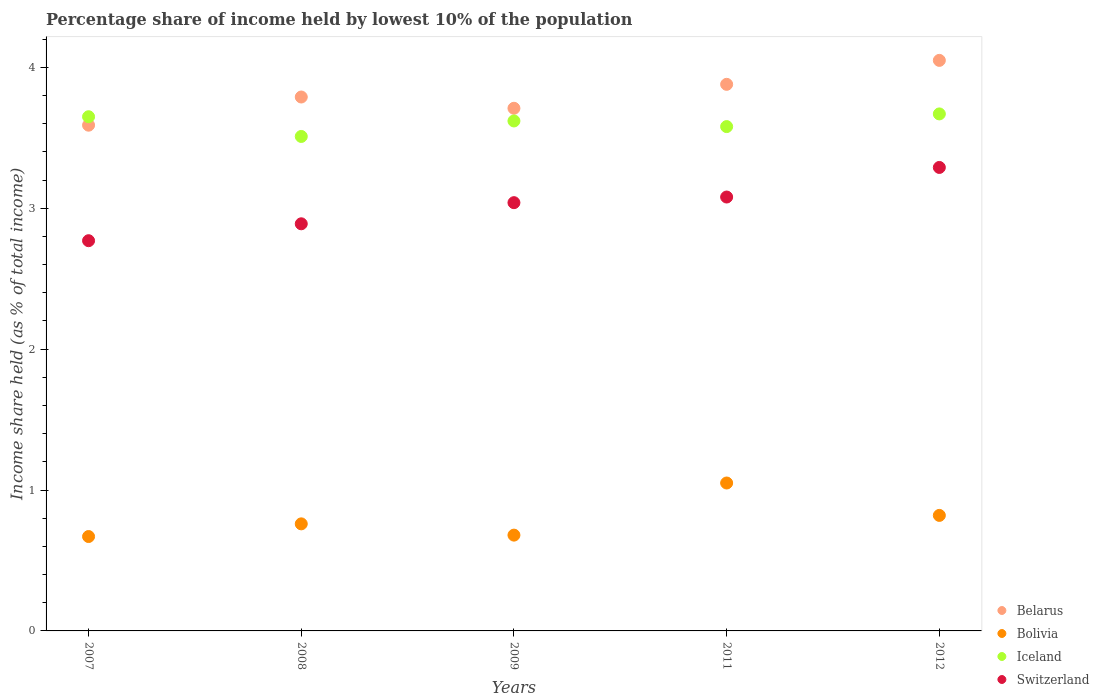Is the number of dotlines equal to the number of legend labels?
Keep it short and to the point. Yes. What is the percentage share of income held by lowest 10% of the population in Switzerland in 2011?
Your response must be concise. 3.08. Across all years, what is the minimum percentage share of income held by lowest 10% of the population in Switzerland?
Provide a short and direct response. 2.77. In which year was the percentage share of income held by lowest 10% of the population in Iceland maximum?
Give a very brief answer. 2012. In which year was the percentage share of income held by lowest 10% of the population in Belarus minimum?
Provide a short and direct response. 2007. What is the total percentage share of income held by lowest 10% of the population in Iceland in the graph?
Offer a terse response. 18.03. What is the difference between the percentage share of income held by lowest 10% of the population in Belarus in 2007 and that in 2008?
Your answer should be very brief. -0.2. What is the difference between the percentage share of income held by lowest 10% of the population in Switzerland in 2011 and the percentage share of income held by lowest 10% of the population in Bolivia in 2007?
Offer a terse response. 2.41. What is the average percentage share of income held by lowest 10% of the population in Iceland per year?
Offer a terse response. 3.61. What is the ratio of the percentage share of income held by lowest 10% of the population in Iceland in 2008 to that in 2011?
Your response must be concise. 0.98. Is the difference between the percentage share of income held by lowest 10% of the population in Iceland in 2007 and 2009 greater than the difference between the percentage share of income held by lowest 10% of the population in Switzerland in 2007 and 2009?
Your response must be concise. Yes. What is the difference between the highest and the second highest percentage share of income held by lowest 10% of the population in Bolivia?
Make the answer very short. 0.23. What is the difference between the highest and the lowest percentage share of income held by lowest 10% of the population in Iceland?
Provide a succinct answer. 0.16. Is the sum of the percentage share of income held by lowest 10% of the population in Switzerland in 2008 and 2011 greater than the maximum percentage share of income held by lowest 10% of the population in Belarus across all years?
Make the answer very short. Yes. Does the percentage share of income held by lowest 10% of the population in Belarus monotonically increase over the years?
Your answer should be very brief. No. Is the percentage share of income held by lowest 10% of the population in Switzerland strictly greater than the percentage share of income held by lowest 10% of the population in Bolivia over the years?
Your answer should be very brief. Yes. How many dotlines are there?
Provide a short and direct response. 4. How many years are there in the graph?
Make the answer very short. 5. Does the graph contain grids?
Your answer should be very brief. No. How many legend labels are there?
Make the answer very short. 4. What is the title of the graph?
Ensure brevity in your answer.  Percentage share of income held by lowest 10% of the population. What is the label or title of the X-axis?
Your answer should be very brief. Years. What is the label or title of the Y-axis?
Keep it short and to the point. Income share held (as % of total income). What is the Income share held (as % of total income) of Belarus in 2007?
Your answer should be very brief. 3.59. What is the Income share held (as % of total income) of Bolivia in 2007?
Offer a terse response. 0.67. What is the Income share held (as % of total income) in Iceland in 2007?
Keep it short and to the point. 3.65. What is the Income share held (as % of total income) in Switzerland in 2007?
Give a very brief answer. 2.77. What is the Income share held (as % of total income) in Belarus in 2008?
Provide a succinct answer. 3.79. What is the Income share held (as % of total income) of Bolivia in 2008?
Offer a terse response. 0.76. What is the Income share held (as % of total income) in Iceland in 2008?
Keep it short and to the point. 3.51. What is the Income share held (as % of total income) of Switzerland in 2008?
Ensure brevity in your answer.  2.89. What is the Income share held (as % of total income) in Belarus in 2009?
Ensure brevity in your answer.  3.71. What is the Income share held (as % of total income) in Bolivia in 2009?
Your response must be concise. 0.68. What is the Income share held (as % of total income) in Iceland in 2009?
Your answer should be compact. 3.62. What is the Income share held (as % of total income) in Switzerland in 2009?
Make the answer very short. 3.04. What is the Income share held (as % of total income) in Belarus in 2011?
Your answer should be compact. 3.88. What is the Income share held (as % of total income) in Iceland in 2011?
Offer a very short reply. 3.58. What is the Income share held (as % of total income) of Switzerland in 2011?
Provide a succinct answer. 3.08. What is the Income share held (as % of total income) of Belarus in 2012?
Provide a short and direct response. 4.05. What is the Income share held (as % of total income) of Bolivia in 2012?
Your response must be concise. 0.82. What is the Income share held (as % of total income) of Iceland in 2012?
Ensure brevity in your answer.  3.67. What is the Income share held (as % of total income) of Switzerland in 2012?
Your answer should be compact. 3.29. Across all years, what is the maximum Income share held (as % of total income) of Belarus?
Provide a short and direct response. 4.05. Across all years, what is the maximum Income share held (as % of total income) in Bolivia?
Your response must be concise. 1.05. Across all years, what is the maximum Income share held (as % of total income) in Iceland?
Make the answer very short. 3.67. Across all years, what is the maximum Income share held (as % of total income) in Switzerland?
Make the answer very short. 3.29. Across all years, what is the minimum Income share held (as % of total income) in Belarus?
Make the answer very short. 3.59. Across all years, what is the minimum Income share held (as % of total income) of Bolivia?
Your answer should be compact. 0.67. Across all years, what is the minimum Income share held (as % of total income) in Iceland?
Your response must be concise. 3.51. Across all years, what is the minimum Income share held (as % of total income) of Switzerland?
Your answer should be very brief. 2.77. What is the total Income share held (as % of total income) in Belarus in the graph?
Provide a succinct answer. 19.02. What is the total Income share held (as % of total income) in Bolivia in the graph?
Provide a succinct answer. 3.98. What is the total Income share held (as % of total income) in Iceland in the graph?
Offer a very short reply. 18.03. What is the total Income share held (as % of total income) of Switzerland in the graph?
Offer a terse response. 15.07. What is the difference between the Income share held (as % of total income) in Belarus in 2007 and that in 2008?
Your answer should be compact. -0.2. What is the difference between the Income share held (as % of total income) in Bolivia in 2007 and that in 2008?
Make the answer very short. -0.09. What is the difference between the Income share held (as % of total income) in Iceland in 2007 and that in 2008?
Your response must be concise. 0.14. What is the difference between the Income share held (as % of total income) of Switzerland in 2007 and that in 2008?
Offer a terse response. -0.12. What is the difference between the Income share held (as % of total income) in Belarus in 2007 and that in 2009?
Give a very brief answer. -0.12. What is the difference between the Income share held (as % of total income) of Bolivia in 2007 and that in 2009?
Provide a short and direct response. -0.01. What is the difference between the Income share held (as % of total income) of Iceland in 2007 and that in 2009?
Give a very brief answer. 0.03. What is the difference between the Income share held (as % of total income) of Switzerland in 2007 and that in 2009?
Your answer should be very brief. -0.27. What is the difference between the Income share held (as % of total income) of Belarus in 2007 and that in 2011?
Make the answer very short. -0.29. What is the difference between the Income share held (as % of total income) of Bolivia in 2007 and that in 2011?
Offer a terse response. -0.38. What is the difference between the Income share held (as % of total income) in Iceland in 2007 and that in 2011?
Provide a short and direct response. 0.07. What is the difference between the Income share held (as % of total income) in Switzerland in 2007 and that in 2011?
Keep it short and to the point. -0.31. What is the difference between the Income share held (as % of total income) of Belarus in 2007 and that in 2012?
Offer a very short reply. -0.46. What is the difference between the Income share held (as % of total income) of Bolivia in 2007 and that in 2012?
Your answer should be compact. -0.15. What is the difference between the Income share held (as % of total income) of Iceland in 2007 and that in 2012?
Provide a short and direct response. -0.02. What is the difference between the Income share held (as % of total income) in Switzerland in 2007 and that in 2012?
Offer a terse response. -0.52. What is the difference between the Income share held (as % of total income) of Iceland in 2008 and that in 2009?
Offer a terse response. -0.11. What is the difference between the Income share held (as % of total income) in Belarus in 2008 and that in 2011?
Offer a terse response. -0.09. What is the difference between the Income share held (as % of total income) in Bolivia in 2008 and that in 2011?
Ensure brevity in your answer.  -0.29. What is the difference between the Income share held (as % of total income) of Iceland in 2008 and that in 2011?
Ensure brevity in your answer.  -0.07. What is the difference between the Income share held (as % of total income) in Switzerland in 2008 and that in 2011?
Your answer should be compact. -0.19. What is the difference between the Income share held (as % of total income) of Belarus in 2008 and that in 2012?
Provide a succinct answer. -0.26. What is the difference between the Income share held (as % of total income) in Bolivia in 2008 and that in 2012?
Your answer should be very brief. -0.06. What is the difference between the Income share held (as % of total income) in Iceland in 2008 and that in 2012?
Offer a terse response. -0.16. What is the difference between the Income share held (as % of total income) in Belarus in 2009 and that in 2011?
Keep it short and to the point. -0.17. What is the difference between the Income share held (as % of total income) in Bolivia in 2009 and that in 2011?
Make the answer very short. -0.37. What is the difference between the Income share held (as % of total income) of Iceland in 2009 and that in 2011?
Offer a very short reply. 0.04. What is the difference between the Income share held (as % of total income) of Switzerland in 2009 and that in 2011?
Keep it short and to the point. -0.04. What is the difference between the Income share held (as % of total income) of Belarus in 2009 and that in 2012?
Your answer should be very brief. -0.34. What is the difference between the Income share held (as % of total income) in Bolivia in 2009 and that in 2012?
Offer a very short reply. -0.14. What is the difference between the Income share held (as % of total income) of Iceland in 2009 and that in 2012?
Make the answer very short. -0.05. What is the difference between the Income share held (as % of total income) in Belarus in 2011 and that in 2012?
Keep it short and to the point. -0.17. What is the difference between the Income share held (as % of total income) of Bolivia in 2011 and that in 2012?
Provide a succinct answer. 0.23. What is the difference between the Income share held (as % of total income) of Iceland in 2011 and that in 2012?
Your answer should be very brief. -0.09. What is the difference between the Income share held (as % of total income) in Switzerland in 2011 and that in 2012?
Your answer should be compact. -0.21. What is the difference between the Income share held (as % of total income) in Belarus in 2007 and the Income share held (as % of total income) in Bolivia in 2008?
Ensure brevity in your answer.  2.83. What is the difference between the Income share held (as % of total income) in Belarus in 2007 and the Income share held (as % of total income) in Switzerland in 2008?
Your response must be concise. 0.7. What is the difference between the Income share held (as % of total income) in Bolivia in 2007 and the Income share held (as % of total income) in Iceland in 2008?
Make the answer very short. -2.84. What is the difference between the Income share held (as % of total income) in Bolivia in 2007 and the Income share held (as % of total income) in Switzerland in 2008?
Offer a terse response. -2.22. What is the difference between the Income share held (as % of total income) of Iceland in 2007 and the Income share held (as % of total income) of Switzerland in 2008?
Offer a terse response. 0.76. What is the difference between the Income share held (as % of total income) of Belarus in 2007 and the Income share held (as % of total income) of Bolivia in 2009?
Ensure brevity in your answer.  2.91. What is the difference between the Income share held (as % of total income) of Belarus in 2007 and the Income share held (as % of total income) of Iceland in 2009?
Ensure brevity in your answer.  -0.03. What is the difference between the Income share held (as % of total income) of Belarus in 2007 and the Income share held (as % of total income) of Switzerland in 2009?
Ensure brevity in your answer.  0.55. What is the difference between the Income share held (as % of total income) in Bolivia in 2007 and the Income share held (as % of total income) in Iceland in 2009?
Offer a terse response. -2.95. What is the difference between the Income share held (as % of total income) of Bolivia in 2007 and the Income share held (as % of total income) of Switzerland in 2009?
Offer a terse response. -2.37. What is the difference between the Income share held (as % of total income) in Iceland in 2007 and the Income share held (as % of total income) in Switzerland in 2009?
Offer a very short reply. 0.61. What is the difference between the Income share held (as % of total income) of Belarus in 2007 and the Income share held (as % of total income) of Bolivia in 2011?
Make the answer very short. 2.54. What is the difference between the Income share held (as % of total income) in Belarus in 2007 and the Income share held (as % of total income) in Switzerland in 2011?
Provide a short and direct response. 0.51. What is the difference between the Income share held (as % of total income) in Bolivia in 2007 and the Income share held (as % of total income) in Iceland in 2011?
Give a very brief answer. -2.91. What is the difference between the Income share held (as % of total income) in Bolivia in 2007 and the Income share held (as % of total income) in Switzerland in 2011?
Provide a succinct answer. -2.41. What is the difference between the Income share held (as % of total income) in Iceland in 2007 and the Income share held (as % of total income) in Switzerland in 2011?
Your response must be concise. 0.57. What is the difference between the Income share held (as % of total income) of Belarus in 2007 and the Income share held (as % of total income) of Bolivia in 2012?
Make the answer very short. 2.77. What is the difference between the Income share held (as % of total income) of Belarus in 2007 and the Income share held (as % of total income) of Iceland in 2012?
Offer a terse response. -0.08. What is the difference between the Income share held (as % of total income) in Belarus in 2007 and the Income share held (as % of total income) in Switzerland in 2012?
Provide a succinct answer. 0.3. What is the difference between the Income share held (as % of total income) of Bolivia in 2007 and the Income share held (as % of total income) of Iceland in 2012?
Your response must be concise. -3. What is the difference between the Income share held (as % of total income) of Bolivia in 2007 and the Income share held (as % of total income) of Switzerland in 2012?
Make the answer very short. -2.62. What is the difference between the Income share held (as % of total income) in Iceland in 2007 and the Income share held (as % of total income) in Switzerland in 2012?
Your answer should be compact. 0.36. What is the difference between the Income share held (as % of total income) in Belarus in 2008 and the Income share held (as % of total income) in Bolivia in 2009?
Keep it short and to the point. 3.11. What is the difference between the Income share held (as % of total income) in Belarus in 2008 and the Income share held (as % of total income) in Iceland in 2009?
Provide a short and direct response. 0.17. What is the difference between the Income share held (as % of total income) in Belarus in 2008 and the Income share held (as % of total income) in Switzerland in 2009?
Provide a succinct answer. 0.75. What is the difference between the Income share held (as % of total income) of Bolivia in 2008 and the Income share held (as % of total income) of Iceland in 2009?
Provide a succinct answer. -2.86. What is the difference between the Income share held (as % of total income) of Bolivia in 2008 and the Income share held (as % of total income) of Switzerland in 2009?
Your answer should be compact. -2.28. What is the difference between the Income share held (as % of total income) in Iceland in 2008 and the Income share held (as % of total income) in Switzerland in 2009?
Your answer should be compact. 0.47. What is the difference between the Income share held (as % of total income) in Belarus in 2008 and the Income share held (as % of total income) in Bolivia in 2011?
Your answer should be compact. 2.74. What is the difference between the Income share held (as % of total income) of Belarus in 2008 and the Income share held (as % of total income) of Iceland in 2011?
Ensure brevity in your answer.  0.21. What is the difference between the Income share held (as % of total income) in Belarus in 2008 and the Income share held (as % of total income) in Switzerland in 2011?
Keep it short and to the point. 0.71. What is the difference between the Income share held (as % of total income) in Bolivia in 2008 and the Income share held (as % of total income) in Iceland in 2011?
Provide a succinct answer. -2.82. What is the difference between the Income share held (as % of total income) in Bolivia in 2008 and the Income share held (as % of total income) in Switzerland in 2011?
Ensure brevity in your answer.  -2.32. What is the difference between the Income share held (as % of total income) of Iceland in 2008 and the Income share held (as % of total income) of Switzerland in 2011?
Your answer should be compact. 0.43. What is the difference between the Income share held (as % of total income) of Belarus in 2008 and the Income share held (as % of total income) of Bolivia in 2012?
Provide a short and direct response. 2.97. What is the difference between the Income share held (as % of total income) of Belarus in 2008 and the Income share held (as % of total income) of Iceland in 2012?
Keep it short and to the point. 0.12. What is the difference between the Income share held (as % of total income) in Bolivia in 2008 and the Income share held (as % of total income) in Iceland in 2012?
Provide a short and direct response. -2.91. What is the difference between the Income share held (as % of total income) in Bolivia in 2008 and the Income share held (as % of total income) in Switzerland in 2012?
Provide a short and direct response. -2.53. What is the difference between the Income share held (as % of total income) of Iceland in 2008 and the Income share held (as % of total income) of Switzerland in 2012?
Make the answer very short. 0.22. What is the difference between the Income share held (as % of total income) in Belarus in 2009 and the Income share held (as % of total income) in Bolivia in 2011?
Give a very brief answer. 2.66. What is the difference between the Income share held (as % of total income) in Belarus in 2009 and the Income share held (as % of total income) in Iceland in 2011?
Provide a short and direct response. 0.13. What is the difference between the Income share held (as % of total income) in Belarus in 2009 and the Income share held (as % of total income) in Switzerland in 2011?
Your response must be concise. 0.63. What is the difference between the Income share held (as % of total income) in Bolivia in 2009 and the Income share held (as % of total income) in Iceland in 2011?
Make the answer very short. -2.9. What is the difference between the Income share held (as % of total income) of Iceland in 2009 and the Income share held (as % of total income) of Switzerland in 2011?
Offer a very short reply. 0.54. What is the difference between the Income share held (as % of total income) in Belarus in 2009 and the Income share held (as % of total income) in Bolivia in 2012?
Offer a very short reply. 2.89. What is the difference between the Income share held (as % of total income) of Belarus in 2009 and the Income share held (as % of total income) of Switzerland in 2012?
Your response must be concise. 0.42. What is the difference between the Income share held (as % of total income) of Bolivia in 2009 and the Income share held (as % of total income) of Iceland in 2012?
Offer a very short reply. -2.99. What is the difference between the Income share held (as % of total income) in Bolivia in 2009 and the Income share held (as % of total income) in Switzerland in 2012?
Your response must be concise. -2.61. What is the difference between the Income share held (as % of total income) in Iceland in 2009 and the Income share held (as % of total income) in Switzerland in 2012?
Offer a very short reply. 0.33. What is the difference between the Income share held (as % of total income) in Belarus in 2011 and the Income share held (as % of total income) in Bolivia in 2012?
Ensure brevity in your answer.  3.06. What is the difference between the Income share held (as % of total income) of Belarus in 2011 and the Income share held (as % of total income) of Iceland in 2012?
Your answer should be very brief. 0.21. What is the difference between the Income share held (as % of total income) of Belarus in 2011 and the Income share held (as % of total income) of Switzerland in 2012?
Provide a succinct answer. 0.59. What is the difference between the Income share held (as % of total income) of Bolivia in 2011 and the Income share held (as % of total income) of Iceland in 2012?
Keep it short and to the point. -2.62. What is the difference between the Income share held (as % of total income) of Bolivia in 2011 and the Income share held (as % of total income) of Switzerland in 2012?
Give a very brief answer. -2.24. What is the difference between the Income share held (as % of total income) of Iceland in 2011 and the Income share held (as % of total income) of Switzerland in 2012?
Your response must be concise. 0.29. What is the average Income share held (as % of total income) of Belarus per year?
Provide a succinct answer. 3.8. What is the average Income share held (as % of total income) of Bolivia per year?
Give a very brief answer. 0.8. What is the average Income share held (as % of total income) in Iceland per year?
Your answer should be compact. 3.61. What is the average Income share held (as % of total income) of Switzerland per year?
Give a very brief answer. 3.01. In the year 2007, what is the difference between the Income share held (as % of total income) in Belarus and Income share held (as % of total income) in Bolivia?
Ensure brevity in your answer.  2.92. In the year 2007, what is the difference between the Income share held (as % of total income) in Belarus and Income share held (as % of total income) in Iceland?
Offer a terse response. -0.06. In the year 2007, what is the difference between the Income share held (as % of total income) of Belarus and Income share held (as % of total income) of Switzerland?
Make the answer very short. 0.82. In the year 2007, what is the difference between the Income share held (as % of total income) in Bolivia and Income share held (as % of total income) in Iceland?
Offer a very short reply. -2.98. In the year 2007, what is the difference between the Income share held (as % of total income) of Iceland and Income share held (as % of total income) of Switzerland?
Keep it short and to the point. 0.88. In the year 2008, what is the difference between the Income share held (as % of total income) in Belarus and Income share held (as % of total income) in Bolivia?
Your response must be concise. 3.03. In the year 2008, what is the difference between the Income share held (as % of total income) of Belarus and Income share held (as % of total income) of Iceland?
Offer a terse response. 0.28. In the year 2008, what is the difference between the Income share held (as % of total income) in Bolivia and Income share held (as % of total income) in Iceland?
Your answer should be compact. -2.75. In the year 2008, what is the difference between the Income share held (as % of total income) in Bolivia and Income share held (as % of total income) in Switzerland?
Ensure brevity in your answer.  -2.13. In the year 2008, what is the difference between the Income share held (as % of total income) of Iceland and Income share held (as % of total income) of Switzerland?
Your answer should be compact. 0.62. In the year 2009, what is the difference between the Income share held (as % of total income) of Belarus and Income share held (as % of total income) of Bolivia?
Offer a very short reply. 3.03. In the year 2009, what is the difference between the Income share held (as % of total income) in Belarus and Income share held (as % of total income) in Iceland?
Offer a very short reply. 0.09. In the year 2009, what is the difference between the Income share held (as % of total income) of Belarus and Income share held (as % of total income) of Switzerland?
Keep it short and to the point. 0.67. In the year 2009, what is the difference between the Income share held (as % of total income) of Bolivia and Income share held (as % of total income) of Iceland?
Provide a short and direct response. -2.94. In the year 2009, what is the difference between the Income share held (as % of total income) in Bolivia and Income share held (as % of total income) in Switzerland?
Ensure brevity in your answer.  -2.36. In the year 2009, what is the difference between the Income share held (as % of total income) in Iceland and Income share held (as % of total income) in Switzerland?
Offer a terse response. 0.58. In the year 2011, what is the difference between the Income share held (as % of total income) in Belarus and Income share held (as % of total income) in Bolivia?
Offer a very short reply. 2.83. In the year 2011, what is the difference between the Income share held (as % of total income) in Belarus and Income share held (as % of total income) in Iceland?
Offer a terse response. 0.3. In the year 2011, what is the difference between the Income share held (as % of total income) of Bolivia and Income share held (as % of total income) of Iceland?
Offer a terse response. -2.53. In the year 2011, what is the difference between the Income share held (as % of total income) in Bolivia and Income share held (as % of total income) in Switzerland?
Keep it short and to the point. -2.03. In the year 2011, what is the difference between the Income share held (as % of total income) of Iceland and Income share held (as % of total income) of Switzerland?
Keep it short and to the point. 0.5. In the year 2012, what is the difference between the Income share held (as % of total income) in Belarus and Income share held (as % of total income) in Bolivia?
Make the answer very short. 3.23. In the year 2012, what is the difference between the Income share held (as % of total income) in Belarus and Income share held (as % of total income) in Iceland?
Your answer should be compact. 0.38. In the year 2012, what is the difference between the Income share held (as % of total income) of Belarus and Income share held (as % of total income) of Switzerland?
Your answer should be compact. 0.76. In the year 2012, what is the difference between the Income share held (as % of total income) of Bolivia and Income share held (as % of total income) of Iceland?
Keep it short and to the point. -2.85. In the year 2012, what is the difference between the Income share held (as % of total income) in Bolivia and Income share held (as % of total income) in Switzerland?
Keep it short and to the point. -2.47. In the year 2012, what is the difference between the Income share held (as % of total income) in Iceland and Income share held (as % of total income) in Switzerland?
Your answer should be compact. 0.38. What is the ratio of the Income share held (as % of total income) of Belarus in 2007 to that in 2008?
Provide a succinct answer. 0.95. What is the ratio of the Income share held (as % of total income) of Bolivia in 2007 to that in 2008?
Your response must be concise. 0.88. What is the ratio of the Income share held (as % of total income) in Iceland in 2007 to that in 2008?
Your answer should be very brief. 1.04. What is the ratio of the Income share held (as % of total income) in Switzerland in 2007 to that in 2008?
Ensure brevity in your answer.  0.96. What is the ratio of the Income share held (as % of total income) of Belarus in 2007 to that in 2009?
Your answer should be compact. 0.97. What is the ratio of the Income share held (as % of total income) of Bolivia in 2007 to that in 2009?
Your answer should be very brief. 0.99. What is the ratio of the Income share held (as % of total income) of Iceland in 2007 to that in 2009?
Keep it short and to the point. 1.01. What is the ratio of the Income share held (as % of total income) of Switzerland in 2007 to that in 2009?
Make the answer very short. 0.91. What is the ratio of the Income share held (as % of total income) in Belarus in 2007 to that in 2011?
Ensure brevity in your answer.  0.93. What is the ratio of the Income share held (as % of total income) of Bolivia in 2007 to that in 2011?
Give a very brief answer. 0.64. What is the ratio of the Income share held (as % of total income) in Iceland in 2007 to that in 2011?
Your response must be concise. 1.02. What is the ratio of the Income share held (as % of total income) in Switzerland in 2007 to that in 2011?
Your response must be concise. 0.9. What is the ratio of the Income share held (as % of total income) in Belarus in 2007 to that in 2012?
Offer a very short reply. 0.89. What is the ratio of the Income share held (as % of total income) of Bolivia in 2007 to that in 2012?
Offer a terse response. 0.82. What is the ratio of the Income share held (as % of total income) in Iceland in 2007 to that in 2012?
Your response must be concise. 0.99. What is the ratio of the Income share held (as % of total income) of Switzerland in 2007 to that in 2012?
Offer a very short reply. 0.84. What is the ratio of the Income share held (as % of total income) of Belarus in 2008 to that in 2009?
Provide a short and direct response. 1.02. What is the ratio of the Income share held (as % of total income) in Bolivia in 2008 to that in 2009?
Give a very brief answer. 1.12. What is the ratio of the Income share held (as % of total income) in Iceland in 2008 to that in 2009?
Offer a very short reply. 0.97. What is the ratio of the Income share held (as % of total income) of Switzerland in 2008 to that in 2009?
Make the answer very short. 0.95. What is the ratio of the Income share held (as % of total income) in Belarus in 2008 to that in 2011?
Offer a very short reply. 0.98. What is the ratio of the Income share held (as % of total income) in Bolivia in 2008 to that in 2011?
Offer a very short reply. 0.72. What is the ratio of the Income share held (as % of total income) in Iceland in 2008 to that in 2011?
Provide a short and direct response. 0.98. What is the ratio of the Income share held (as % of total income) in Switzerland in 2008 to that in 2011?
Provide a succinct answer. 0.94. What is the ratio of the Income share held (as % of total income) in Belarus in 2008 to that in 2012?
Provide a short and direct response. 0.94. What is the ratio of the Income share held (as % of total income) of Bolivia in 2008 to that in 2012?
Make the answer very short. 0.93. What is the ratio of the Income share held (as % of total income) in Iceland in 2008 to that in 2012?
Offer a very short reply. 0.96. What is the ratio of the Income share held (as % of total income) in Switzerland in 2008 to that in 2012?
Provide a short and direct response. 0.88. What is the ratio of the Income share held (as % of total income) of Belarus in 2009 to that in 2011?
Offer a terse response. 0.96. What is the ratio of the Income share held (as % of total income) in Bolivia in 2009 to that in 2011?
Provide a succinct answer. 0.65. What is the ratio of the Income share held (as % of total income) of Iceland in 2009 to that in 2011?
Offer a very short reply. 1.01. What is the ratio of the Income share held (as % of total income) of Belarus in 2009 to that in 2012?
Provide a succinct answer. 0.92. What is the ratio of the Income share held (as % of total income) of Bolivia in 2009 to that in 2012?
Provide a short and direct response. 0.83. What is the ratio of the Income share held (as % of total income) in Iceland in 2009 to that in 2012?
Your response must be concise. 0.99. What is the ratio of the Income share held (as % of total income) of Switzerland in 2009 to that in 2012?
Offer a very short reply. 0.92. What is the ratio of the Income share held (as % of total income) in Belarus in 2011 to that in 2012?
Provide a succinct answer. 0.96. What is the ratio of the Income share held (as % of total income) of Bolivia in 2011 to that in 2012?
Offer a terse response. 1.28. What is the ratio of the Income share held (as % of total income) of Iceland in 2011 to that in 2012?
Your answer should be compact. 0.98. What is the ratio of the Income share held (as % of total income) of Switzerland in 2011 to that in 2012?
Provide a short and direct response. 0.94. What is the difference between the highest and the second highest Income share held (as % of total income) in Belarus?
Provide a succinct answer. 0.17. What is the difference between the highest and the second highest Income share held (as % of total income) of Bolivia?
Make the answer very short. 0.23. What is the difference between the highest and the second highest Income share held (as % of total income) in Iceland?
Provide a short and direct response. 0.02. What is the difference between the highest and the second highest Income share held (as % of total income) of Switzerland?
Keep it short and to the point. 0.21. What is the difference between the highest and the lowest Income share held (as % of total income) of Belarus?
Your response must be concise. 0.46. What is the difference between the highest and the lowest Income share held (as % of total income) of Bolivia?
Provide a short and direct response. 0.38. What is the difference between the highest and the lowest Income share held (as % of total income) of Iceland?
Your answer should be compact. 0.16. What is the difference between the highest and the lowest Income share held (as % of total income) in Switzerland?
Your response must be concise. 0.52. 